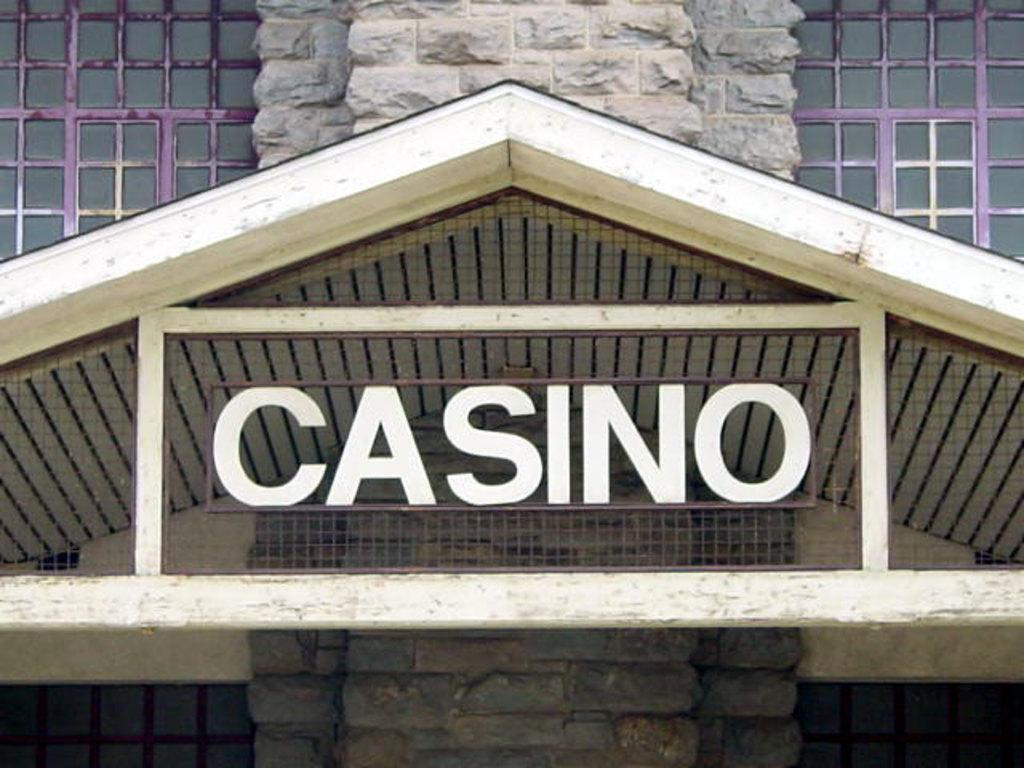What part of a building can be seen in the image? The roof is visible in the image. What type of fence is present in the image? There is a metal grill fence in the image. What material are the windows made of in the image? Glass windows are present in the image. What type of juice is being served in the image? There is no juice present in the image; it features a roof, metal grill fence, and glass windows. In which direction is the building facing in the image? The image does not provide enough information to determine the direction the building is facing. 